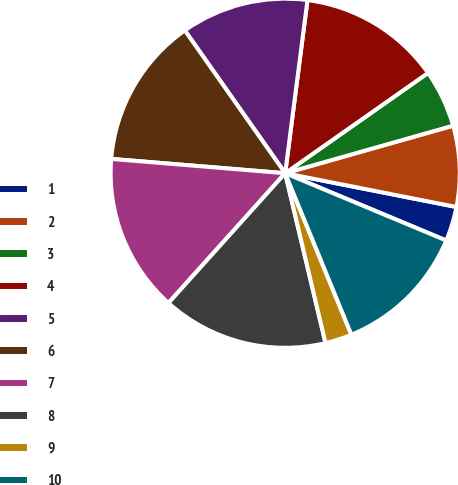Convert chart. <chart><loc_0><loc_0><loc_500><loc_500><pie_chart><fcel>1<fcel>2<fcel>3<fcel>4<fcel>5<fcel>6<fcel>7<fcel>8<fcel>9<fcel>10<nl><fcel>3.2%<fcel>7.49%<fcel>5.35%<fcel>13.22%<fcel>11.79%<fcel>13.94%<fcel>14.65%<fcel>15.37%<fcel>2.48%<fcel>12.51%<nl></chart> 